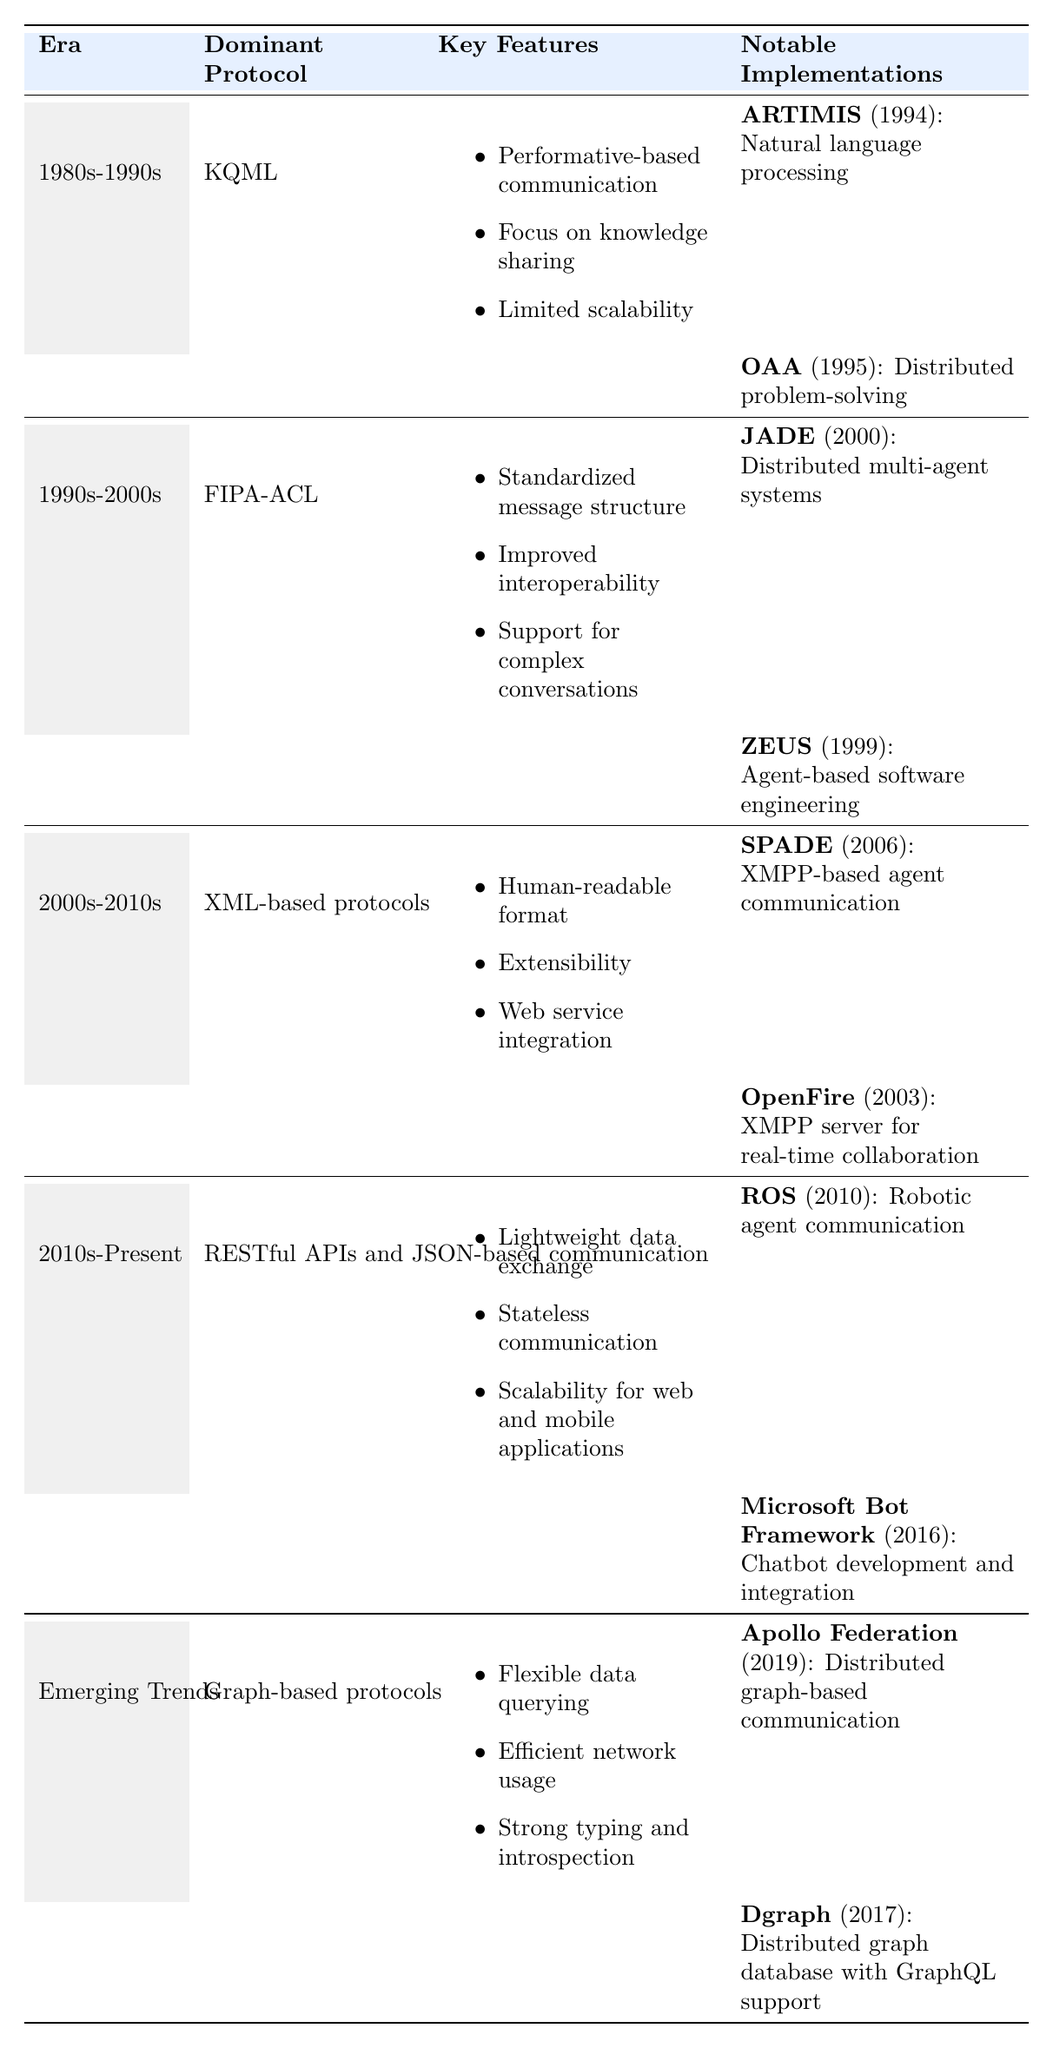What was the dominant protocol in the 2000s-2010s era? The table specifies that the dominant protocol during the 2000s-2010s era was XML-based protocols.
Answer: XML-based protocols What are the key features of the FIPA-ACL protocol? According to the table, the key features of FIPA-ACL include standardized message structure, improved interoperability, and support for complex conversations.
Answer: Standardized message structure, improved interoperability, support for complex conversations Which implementation was notable for natural language processing? The table lists ARTIMIS as a notable implementation for natural language processing in the 1980s-1990s era.
Answer: ARTIMIS How many notable implementations are listed for the "Emerging Trends" era? There are two notable implementations listed for the "Emerging Trends" era: Apollo Federation and Dgraph.
Answer: Two Did the RESTful APIs and JSON-based communication era contribute to data exchange? Yes, the table indicates that RESTful APIs and JSON-based communication are characterized by lightweight data exchange.
Answer: Yes Which protocol has a focus on knowledge sharing? The protocol with a focus on knowledge sharing is KQML, as indicated in the table for the 1980s-1990s era.
Answer: KQML Which era introduced protocols that support complex conversations? The FIPA-ACL protocol from the 1990s-2000s era introduced support for complex conversations.
Answer: 1990s-2000s What is the most recent notable implementation listed in the table? The most recent notable implementation is Microsoft Bot Framework, which was implemented in 2016.
Answer: Microsoft Bot Framework Compare the scalability features between the KQML and RESTful APIs. KQML has limited scalability, while RESTful APIs and JSON-based communication offer scalability for web and mobile applications.
Answer: RESTful APIs are scalable, KQML is limited Which two protocols were used for agent communication in different formats? XML-based protocols (e.g., SOAP, XMPP) and Graph-based protocols (e.g., GraphQL) were both used for agent communication in different formats.
Answer: XML-based and Graph-based protocols How has communication evolution impacted interoperability? The transition from KQML to FIPA-ACL improved interoperability through a standardized message structure, indicating a significant impact on how systems communicate.
Answer: Improved interoperability 